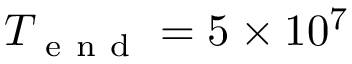<formula> <loc_0><loc_0><loc_500><loc_500>T _ { e n d } = 5 \times 1 0 ^ { 7 }</formula> 